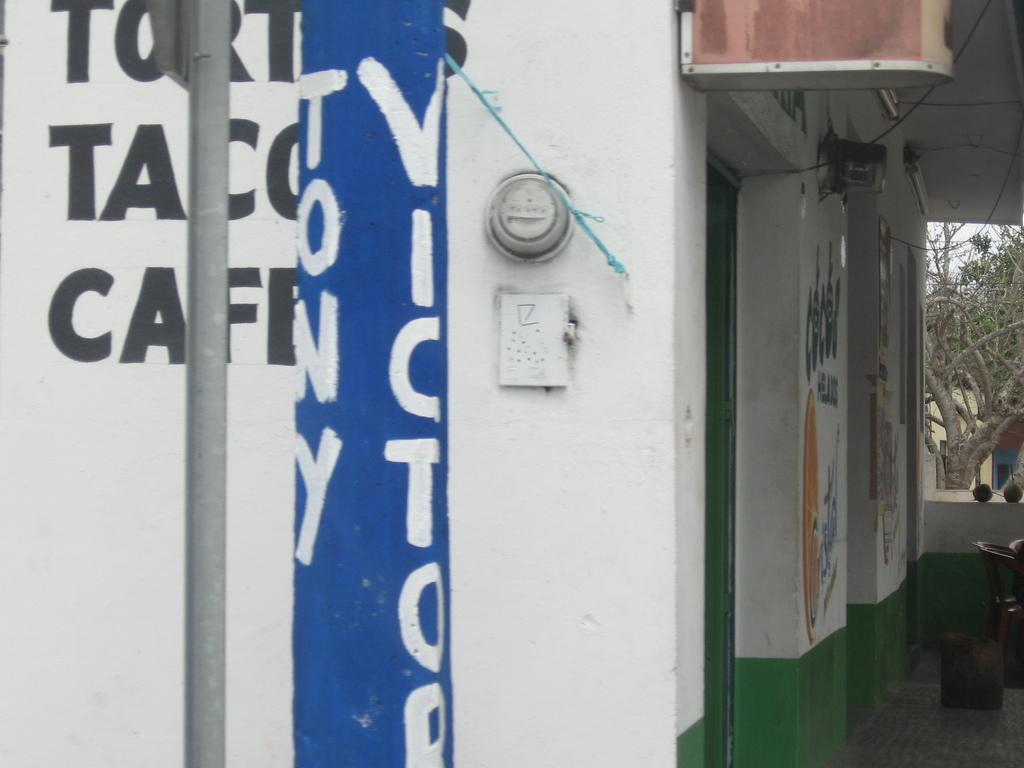What is the main structure in the center of the image? There is a building in the center of the image. What can be found on the wall in the image? There is a wall with text in the image. What other object is present in the image? There is a pole in the image. What can be seen in the background of the image? There are trees in the background of the image. How many planes are flying over the building in the image? There are no planes visible in the image; it only features a building, a wall with text, a pole, and trees in the background. 